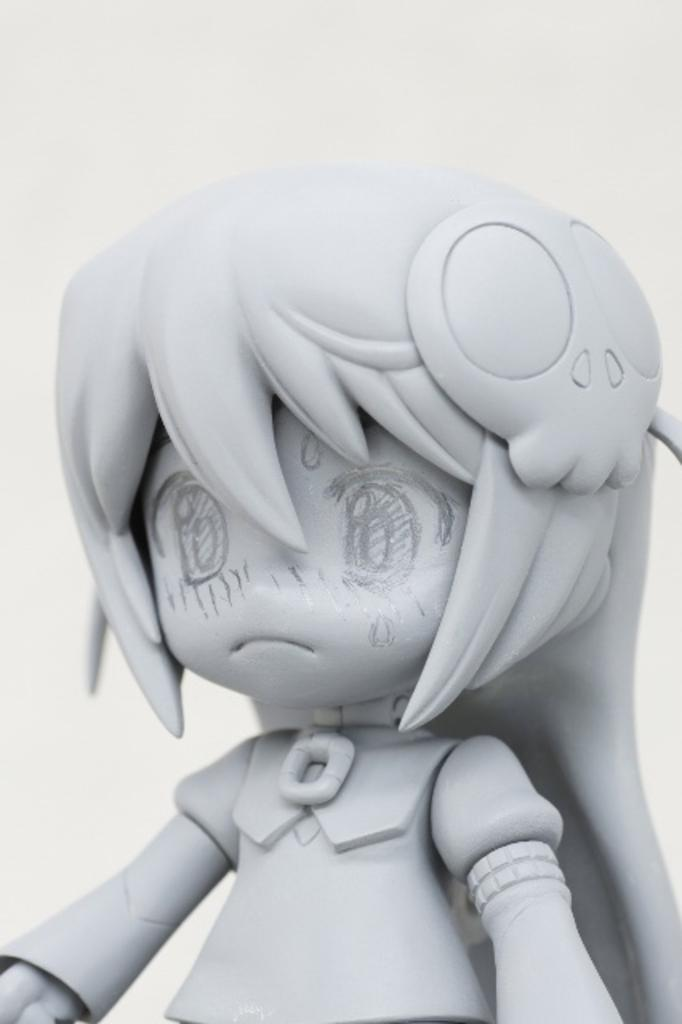What type of character is depicted in the image? There is a cartoon character in the image. What is the plot of the story involving the desk and the character's attempt in the image? There is no story, desk, or attempt present in the image; it only features a cartoon character. 